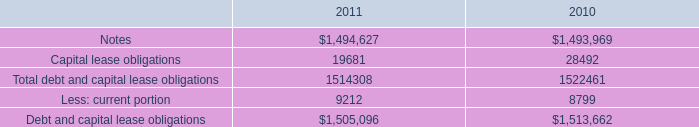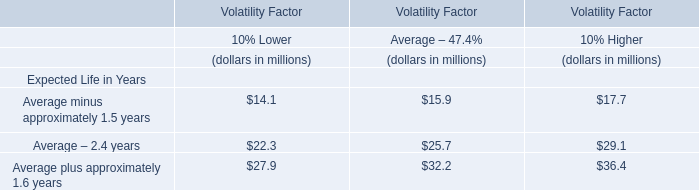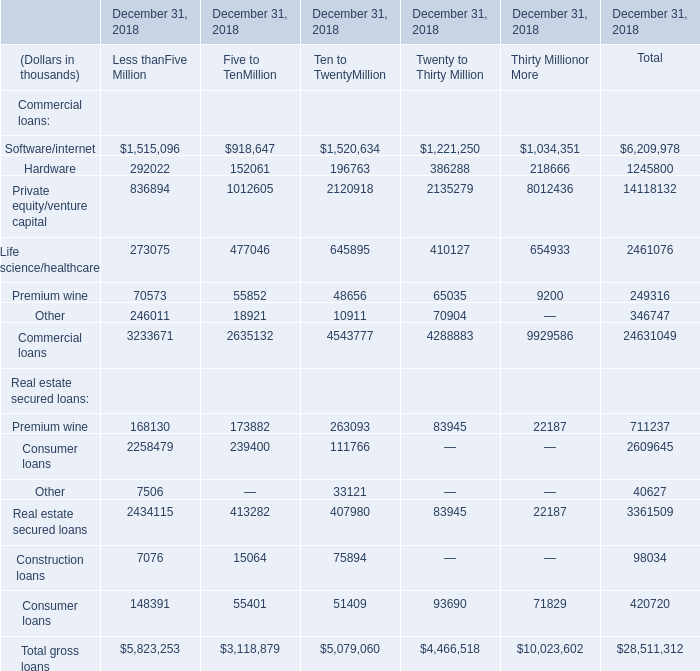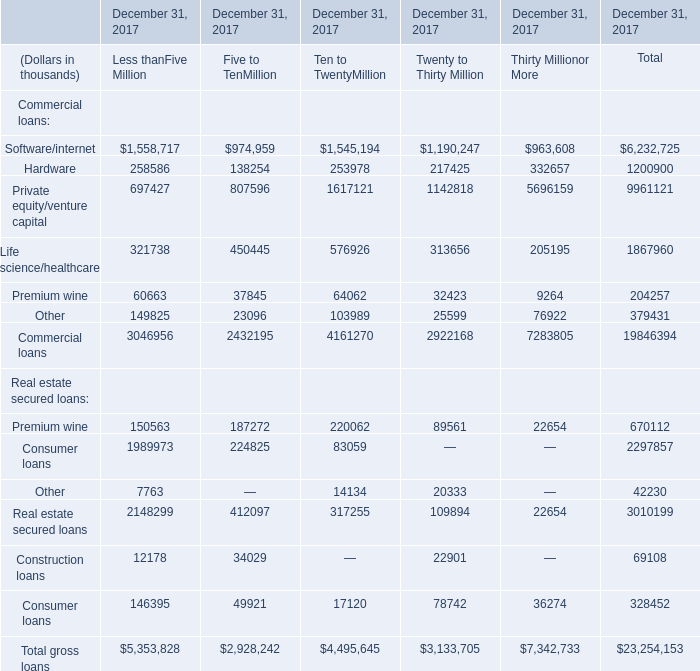What is the sum of Commercial loans of December 31, 2018 Twenty to Thirty Million, and Private equity/venture capital of December 31, 2017 Five to TenMillion ? 
Computations: (4288883.0 + 807596.0)
Answer: 5096479.0. 